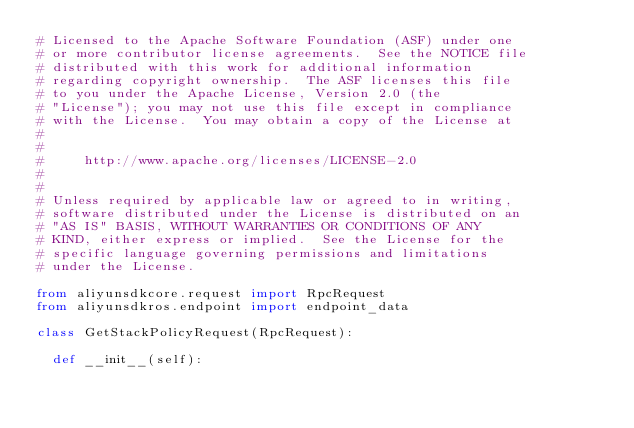<code> <loc_0><loc_0><loc_500><loc_500><_Python_># Licensed to the Apache Software Foundation (ASF) under one
# or more contributor license agreements.  See the NOTICE file
# distributed with this work for additional information
# regarding copyright ownership.  The ASF licenses this file
# to you under the Apache License, Version 2.0 (the
# "License"); you may not use this file except in compliance
# with the License.  You may obtain a copy of the License at
#
#
#     http://www.apache.org/licenses/LICENSE-2.0
#
#
# Unless required by applicable law or agreed to in writing,
# software distributed under the License is distributed on an
# "AS IS" BASIS, WITHOUT WARRANTIES OR CONDITIONS OF ANY
# KIND, either express or implied.  See the License for the
# specific language governing permissions and limitations
# under the License.

from aliyunsdkcore.request import RpcRequest
from aliyunsdkros.endpoint import endpoint_data

class GetStackPolicyRequest(RpcRequest):

	def __init__(self):</code> 